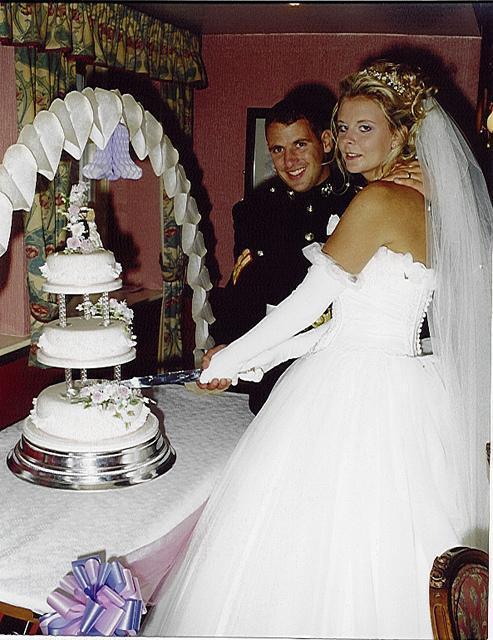How many people are in the picture?
Give a very brief answer. 2. 